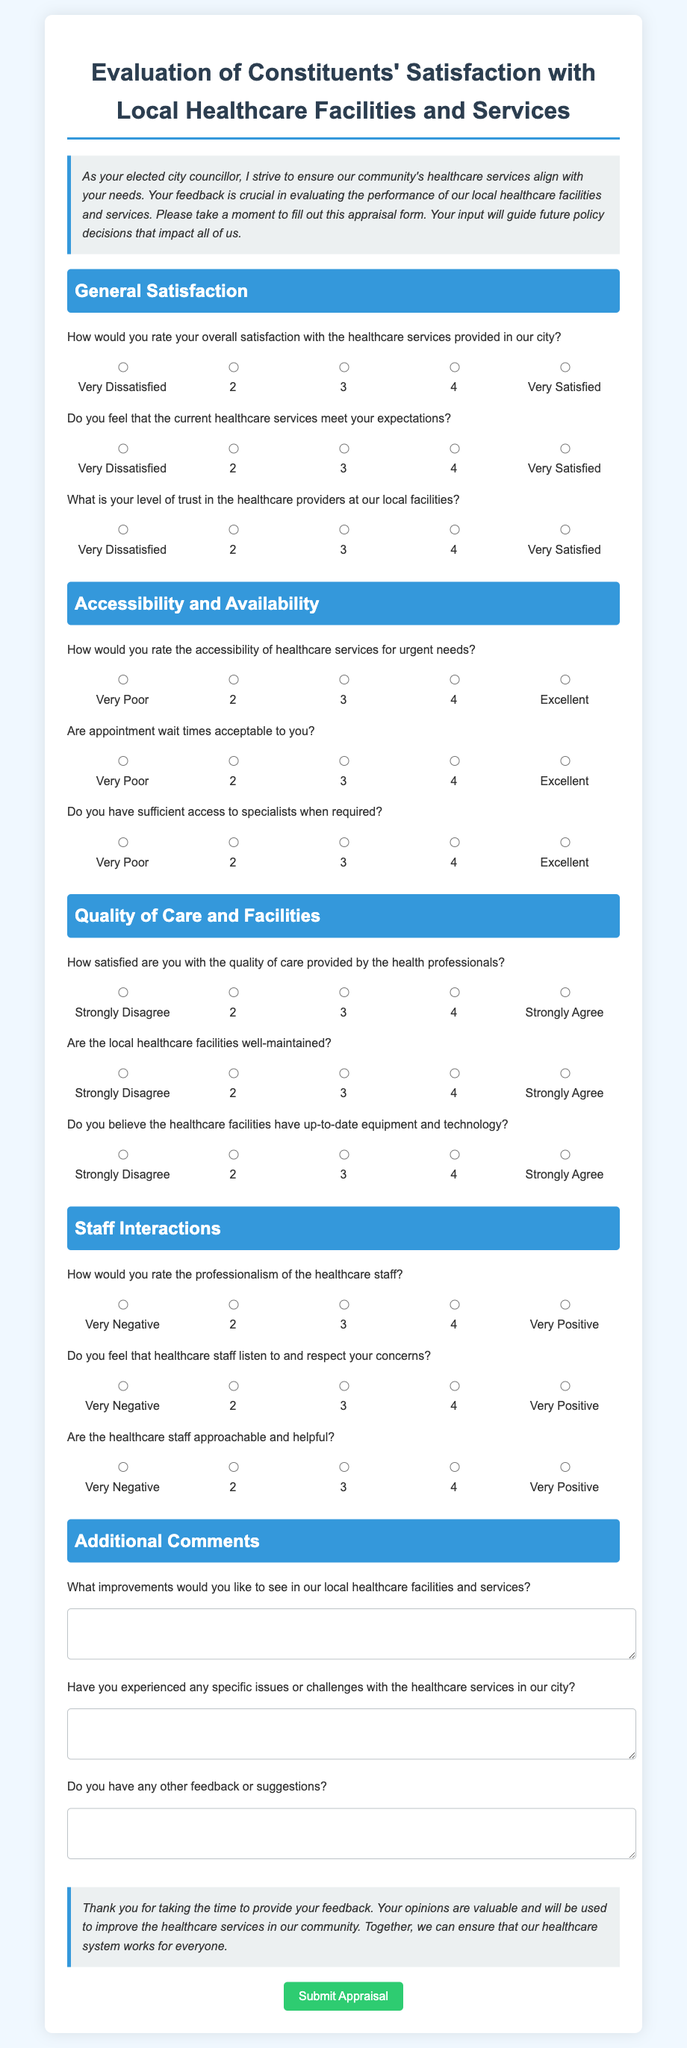What is the title of the appraisal form? The title is the main heading of the document that indicates its purpose, which is "Evaluation of Constituents' Satisfaction with Local Healthcare Facilities and Services."
Answer: Evaluation of Constituents' Satisfaction with Local Healthcare Facilities and Services How many sections are in the appraisal form? The document is divided into several sections, each addressing a specific area of feedback; there are five sections listed.
Answer: 5 What is the first question under the "General Satisfaction" section? The first question in this section asks about the overall satisfaction level of healthcare services provided in the city.
Answer: How would you rate your overall satisfaction with the healthcare services provided in our city? What is the scale used for rating in the document? The document includes a rating scale that ranges from 1 to 5, where 1 indicates very dissatisfied, and 5 indicates very satisfied.
Answer: 1 to 5 What kind of feedback is requested in the "Additional Comments" section? This section asks for suggestions, improvements, and any specific issues experienced with healthcare services, allowing constituents to provide qualitative feedback.
Answer: Improvements and specific issues What does the last question in the "Staff Interactions" section ask? It inquires whether healthcare staff are approachable and helpful, seeking to assess the interpersonal dynamics between staff and patients.
Answer: Are the healthcare staff approachable and helpful? What color represents the section titles? The section titles are highlighted in blue to distinguish them clearly from other text in the document.
Answer: Blue What is the main objective of the evaluation form? The evaluation form aims to collect feedback from constituents to inform future health policy decisions and improve local healthcare services.
Answer: Collect feedback to inform health policy decisions 